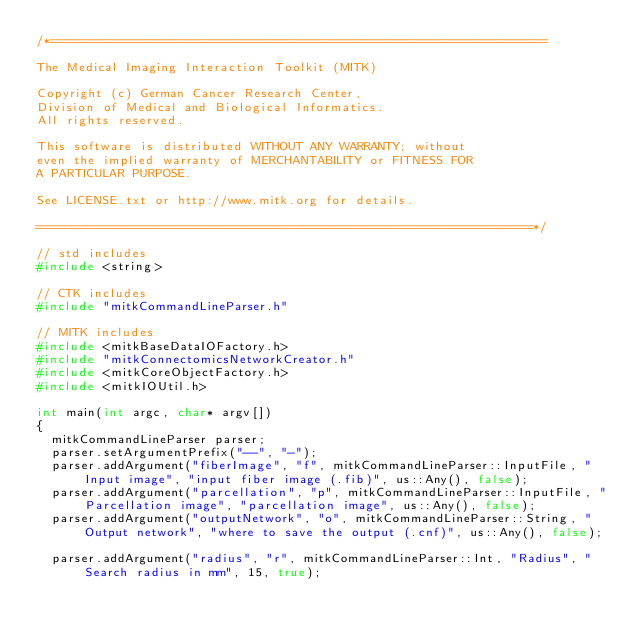<code> <loc_0><loc_0><loc_500><loc_500><_C++_>/*===================================================================

The Medical Imaging Interaction Toolkit (MITK)

Copyright (c) German Cancer Research Center,
Division of Medical and Biological Informatics.
All rights reserved.

This software is distributed WITHOUT ANY WARRANTY; without
even the implied warranty of MERCHANTABILITY or FITNESS FOR
A PARTICULAR PURPOSE.

See LICENSE.txt or http://www.mitk.org for details.

===================================================================*/

// std includes
#include <string>

// CTK includes
#include "mitkCommandLineParser.h"

// MITK includes
#include <mitkBaseDataIOFactory.h>
#include "mitkConnectomicsNetworkCreator.h"
#include <mitkCoreObjectFactory.h>
#include <mitkIOUtil.h>

int main(int argc, char* argv[])
{
  mitkCommandLineParser parser;
  parser.setArgumentPrefix("--", "-");
  parser.addArgument("fiberImage", "f", mitkCommandLineParser::InputFile, "Input image", "input fiber image (.fib)", us::Any(), false);
  parser.addArgument("parcellation", "p", mitkCommandLineParser::InputFile, "Parcellation image", "parcellation image", us::Any(), false);
  parser.addArgument("outputNetwork", "o", mitkCommandLineParser::String, "Output network", "where to save the output (.cnf)", us::Any(), false);

  parser.addArgument("radius", "r", mitkCommandLineParser::Int, "Radius", "Search radius in mm", 15, true);</code> 